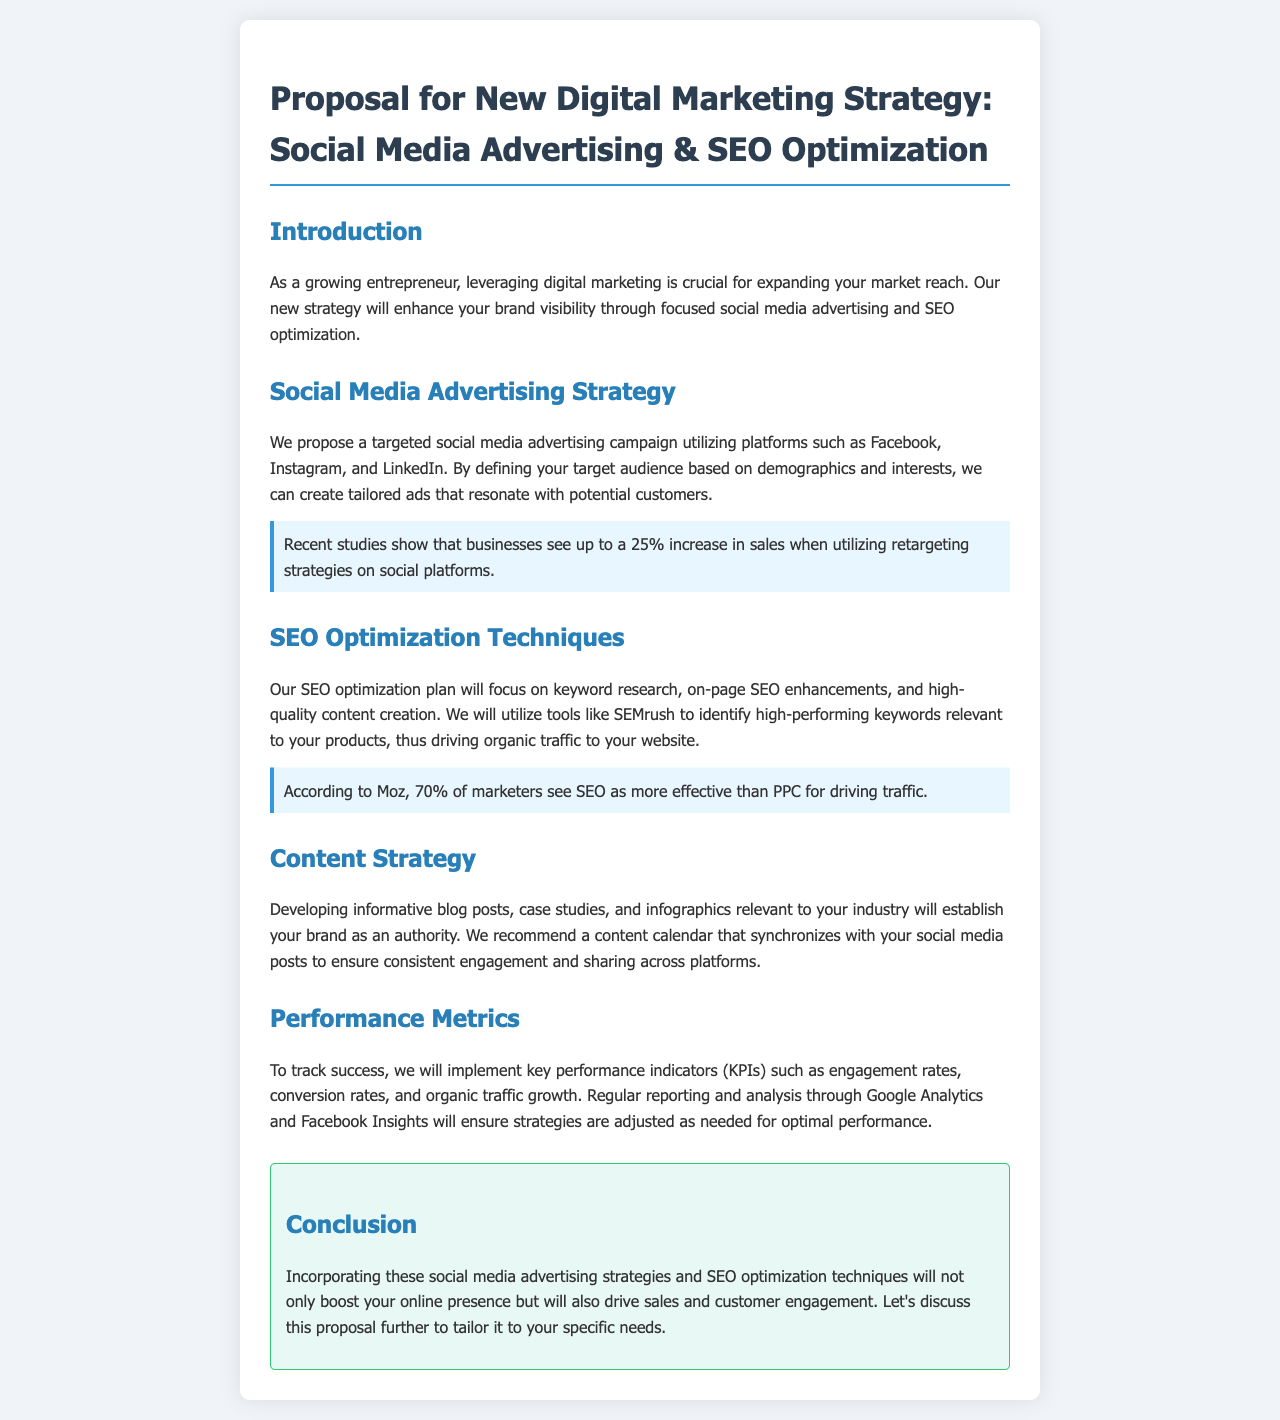What is the main focus of the proposed strategy? The main focus of the proposed strategy is enhancing brand visibility through social media advertising and SEO optimization.
Answer: brand visibility Which platforms are mentioned for social media advertising? The platforms mentioned for social media advertising are Facebook, Instagram, and LinkedIn.
Answer: Facebook, Instagram, LinkedIn What percentage increase in sales is reported from retargeting strategies? Recent studies show that businesses see up to a 25% increase in sales when utilizing retargeting strategies.
Answer: 25% What tool is recommended for keyword research? The tool recommended for keyword research is SEMrush.
Answer: SEMrush What do 70% of marketers consider more effective than PPC for driving traffic? According to Moz, 70% of marketers see SEO as more effective than PPC for driving traffic.
Answer: SEO How will the performance be tracked? Performance will be tracked through key performance indicators (KPIs) such as engagement rates, conversion rates, and organic traffic growth.
Answer: KPIs What type of content is suggested to establish the brand as an authority? Developing informative blog posts, case studies, and infographics is suggested to establish the brand as an authority.
Answer: blog posts, case studies, infographics What is the purpose of the content calendar? The purpose of the content calendar is to ensure consistent engagement and sharing across platforms.
Answer: consistent engagement What will report and analysis tools be used? Regular reporting and analysis will be done through Google Analytics and Facebook Insights.
Answer: Google Analytics, Facebook Insights 